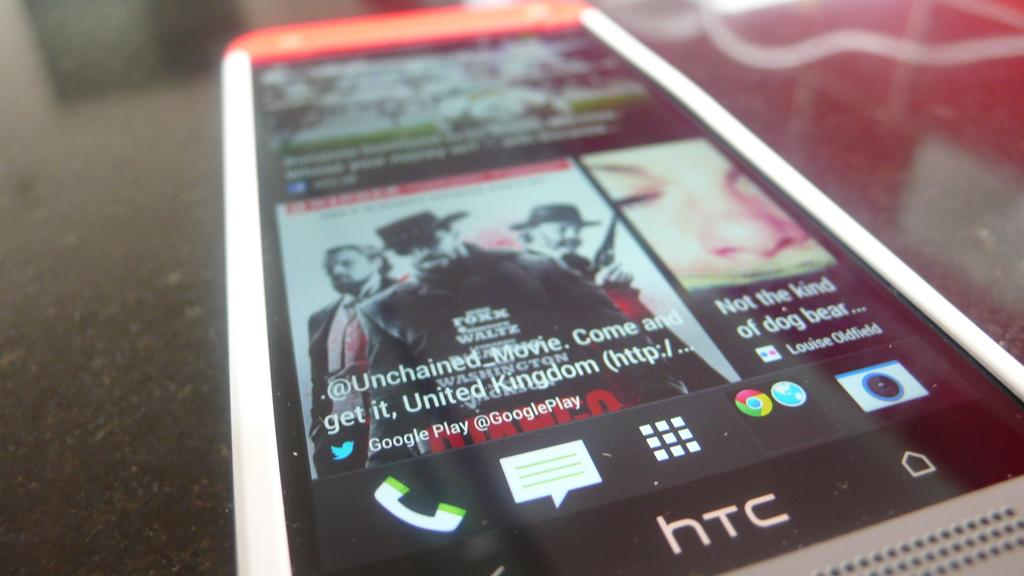What is the main subject of the image? The main subject of the image is a mobile. What can be seen on the screen of the mobile? The screen of the mobile has icons, photos, and words. What is the mobile placed on in the image? The mobile is on an object. How many lizards are crawling on the mobile in the image? There are no lizards present in the image. What type of shoes is the person wearing who is holding the mobile in the image? There is no person holding the mobile in the image, and therefore no shoes can be observed. 